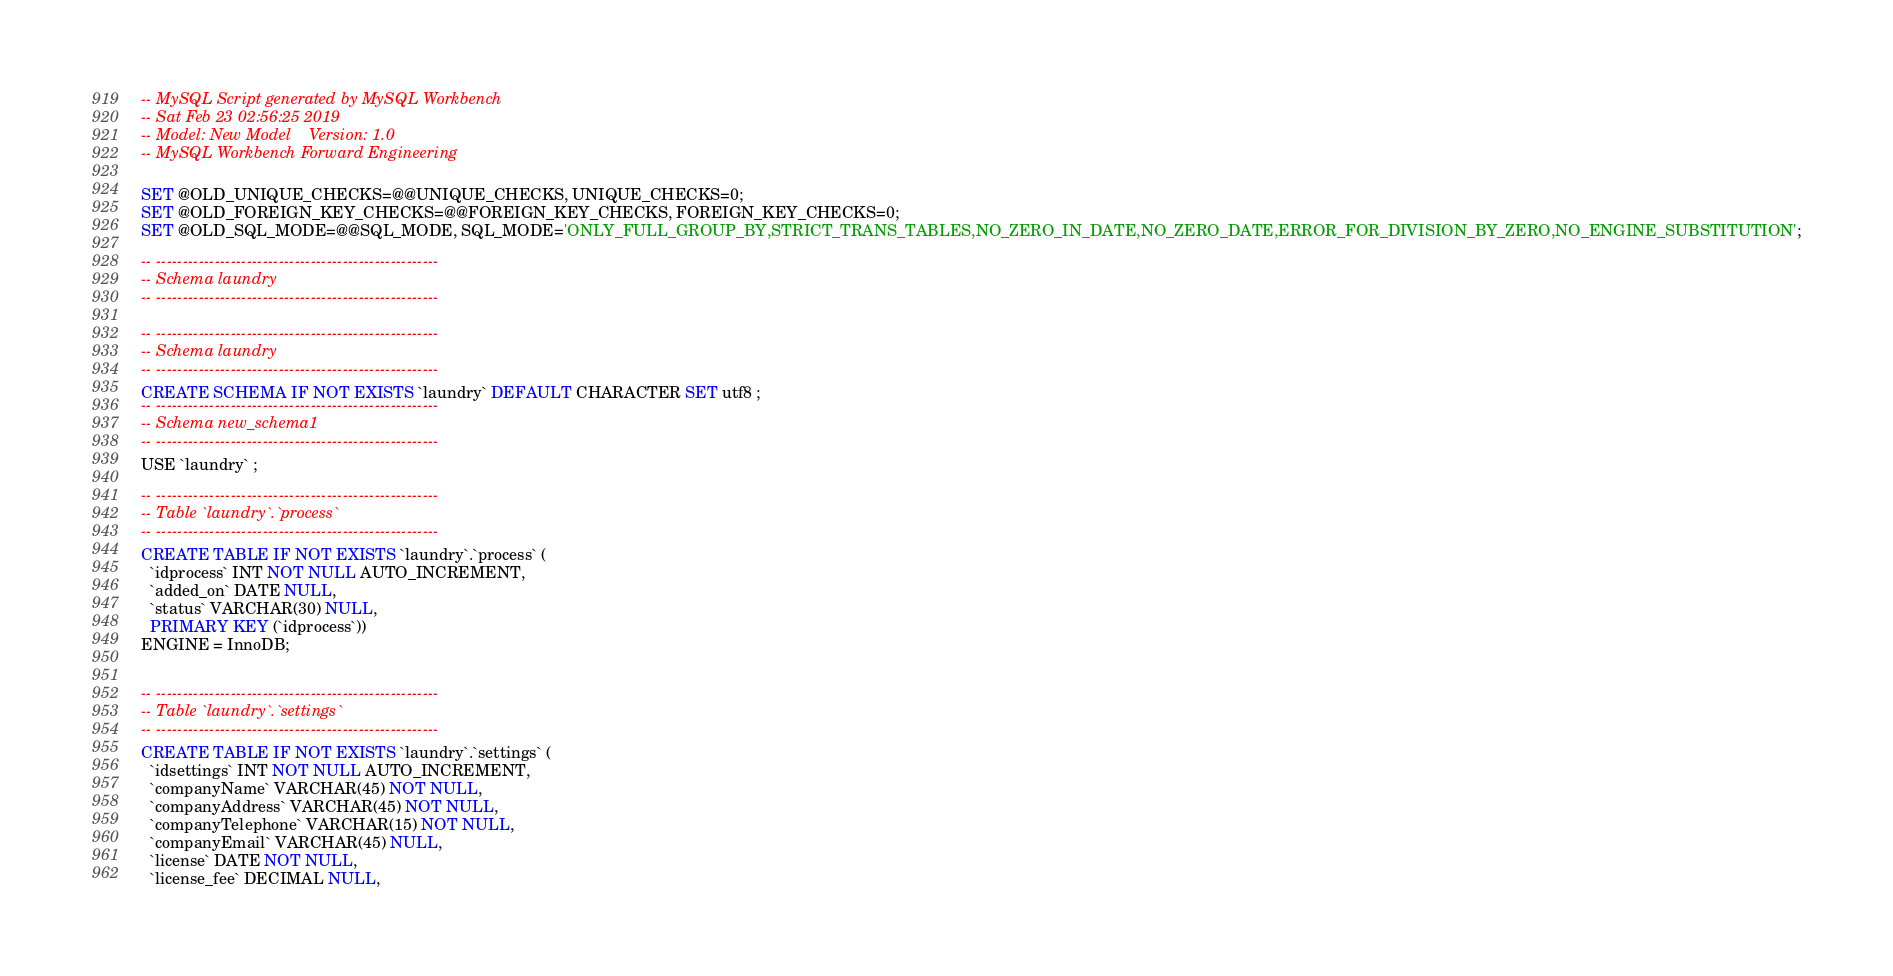<code> <loc_0><loc_0><loc_500><loc_500><_SQL_>-- MySQL Script generated by MySQL Workbench
-- Sat Feb 23 02:56:25 2019
-- Model: New Model    Version: 1.0
-- MySQL Workbench Forward Engineering

SET @OLD_UNIQUE_CHECKS=@@UNIQUE_CHECKS, UNIQUE_CHECKS=0;
SET @OLD_FOREIGN_KEY_CHECKS=@@FOREIGN_KEY_CHECKS, FOREIGN_KEY_CHECKS=0;
SET @OLD_SQL_MODE=@@SQL_MODE, SQL_MODE='ONLY_FULL_GROUP_BY,STRICT_TRANS_TABLES,NO_ZERO_IN_DATE,NO_ZERO_DATE,ERROR_FOR_DIVISION_BY_ZERO,NO_ENGINE_SUBSTITUTION';

-- -----------------------------------------------------
-- Schema laundry
-- -----------------------------------------------------

-- -----------------------------------------------------
-- Schema laundry
-- -----------------------------------------------------
CREATE SCHEMA IF NOT EXISTS `laundry` DEFAULT CHARACTER SET utf8 ;
-- -----------------------------------------------------
-- Schema new_schema1
-- -----------------------------------------------------
USE `laundry` ;

-- -----------------------------------------------------
-- Table `laundry`.`process`
-- -----------------------------------------------------
CREATE TABLE IF NOT EXISTS `laundry`.`process` (
  `idprocess` INT NOT NULL AUTO_INCREMENT,
  `added_on` DATE NULL,
  `status` VARCHAR(30) NULL,
  PRIMARY KEY (`idprocess`))
ENGINE = InnoDB;


-- -----------------------------------------------------
-- Table `laundry`.`settings`
-- -----------------------------------------------------
CREATE TABLE IF NOT EXISTS `laundry`.`settings` (
  `idsettings` INT NOT NULL AUTO_INCREMENT,
  `companyName` VARCHAR(45) NOT NULL,
  `companyAddress` VARCHAR(45) NOT NULL,
  `companyTelephone` VARCHAR(15) NOT NULL,
  `companyEmail` VARCHAR(45) NULL,
  `license` DATE NOT NULL,
  `license_fee` DECIMAL NULL,</code> 